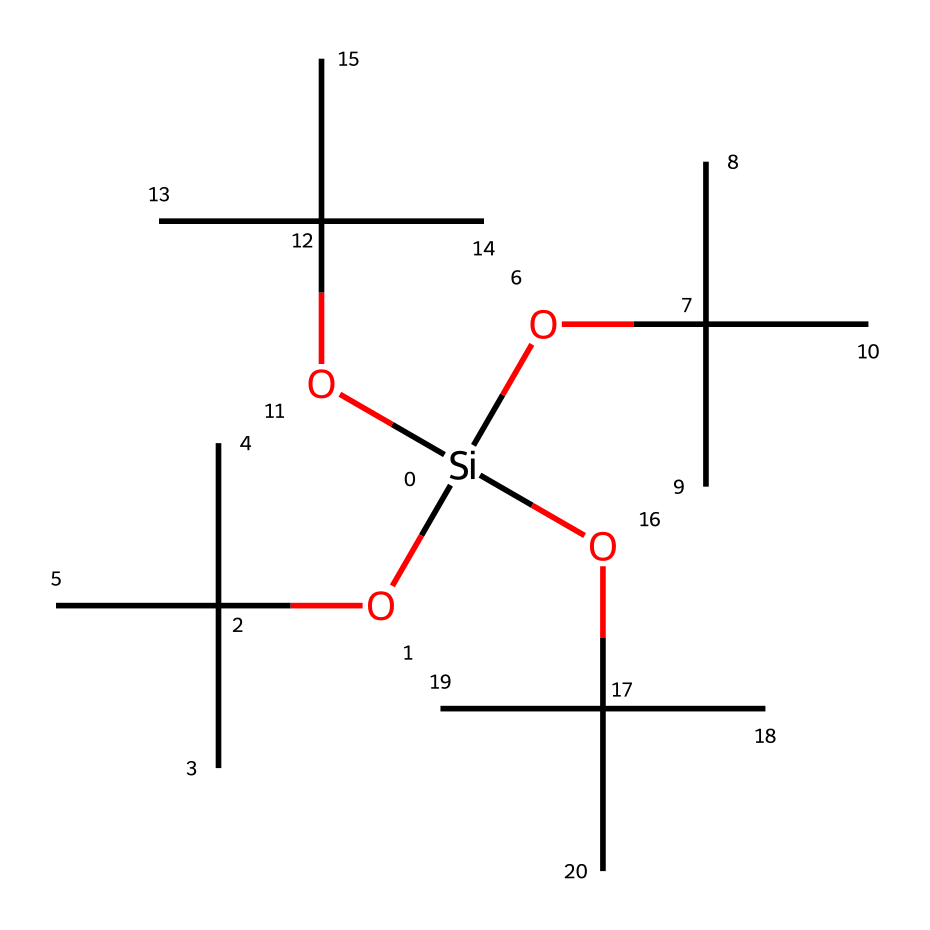What is the central atom in this organosilicon compound? The central atom in organosilicon compounds is silicon, which is evident in the SMILES where it is represented by [Si].
Answer: silicon How many carbon atoms are present in this compound? By examining the structure, each branching connected to the silicon contains one carbon from the groups OC(C)(C)C, and there are four such groups. Each group contributes a total of three carbon atoms (the group plus the two branching alkyl groups). Hence, the total is 12 carbon atoms.
Answer: 12 What type of groups are represented by OC(C)(C)C in this compound? The notation OC(C)(C)C indicates an alkoxy group due to the presence of the oxygen atom connected to the carbon chain. The branching indicates that it is a tert-butyl group, which is an alkyl derivative.
Answer: alkoxy groups How many oxygen atoms are in this structure? Each OC(C)(C)C contributes one oxygen atom connected to the silicon atom. Since there are four OC(C)(C)C groups, the total number of oxygen atoms is four.
Answer: 4 What type of chemical bonding is primarily present in organosilicon compounds? In this structure, the bonding mainly consists of covalent bonds between silicon and carbon/oxygen atoms, as indicated by the connections in the SMILES notation.
Answer: covalent bonds Which property of this organosilicon compound contributes to flame retardancy? The presence of silicon atoms in the structure contributes to flame retardancy due to the formation of a protective layer when exposed to heat, which inhibits combustion.
Answer: silicon 